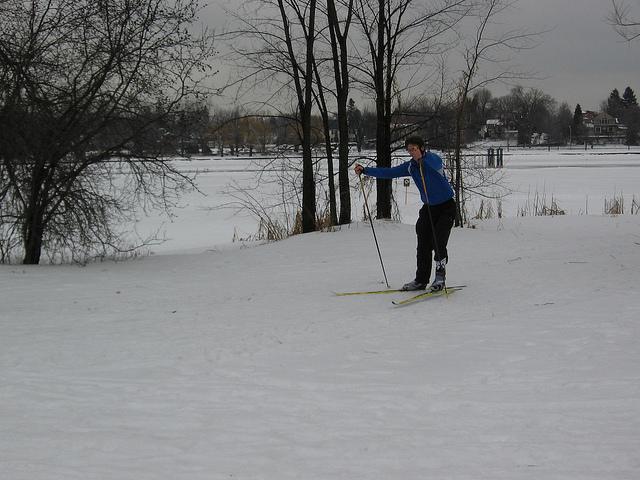What is this person doing?
Quick response, please. Skiing. How many people are in this image?
Short answer required. 1. Is there a shadow of a tree in the foreground?
Write a very short answer. No. What is the man doing?
Answer briefly. Skiing. What color is the sky?
Short answer required. Gray. What is the person wearing?
Quick response, please. Ski clothes. Did someone forget his luggage in the snow?
Keep it brief. No. What color is his coat?
Concise answer only. Blue. Is it daytime?
Short answer required. Yes. What is she holding?
Write a very short answer. Poles. Is the person wearing a hat?
Concise answer only. No. 